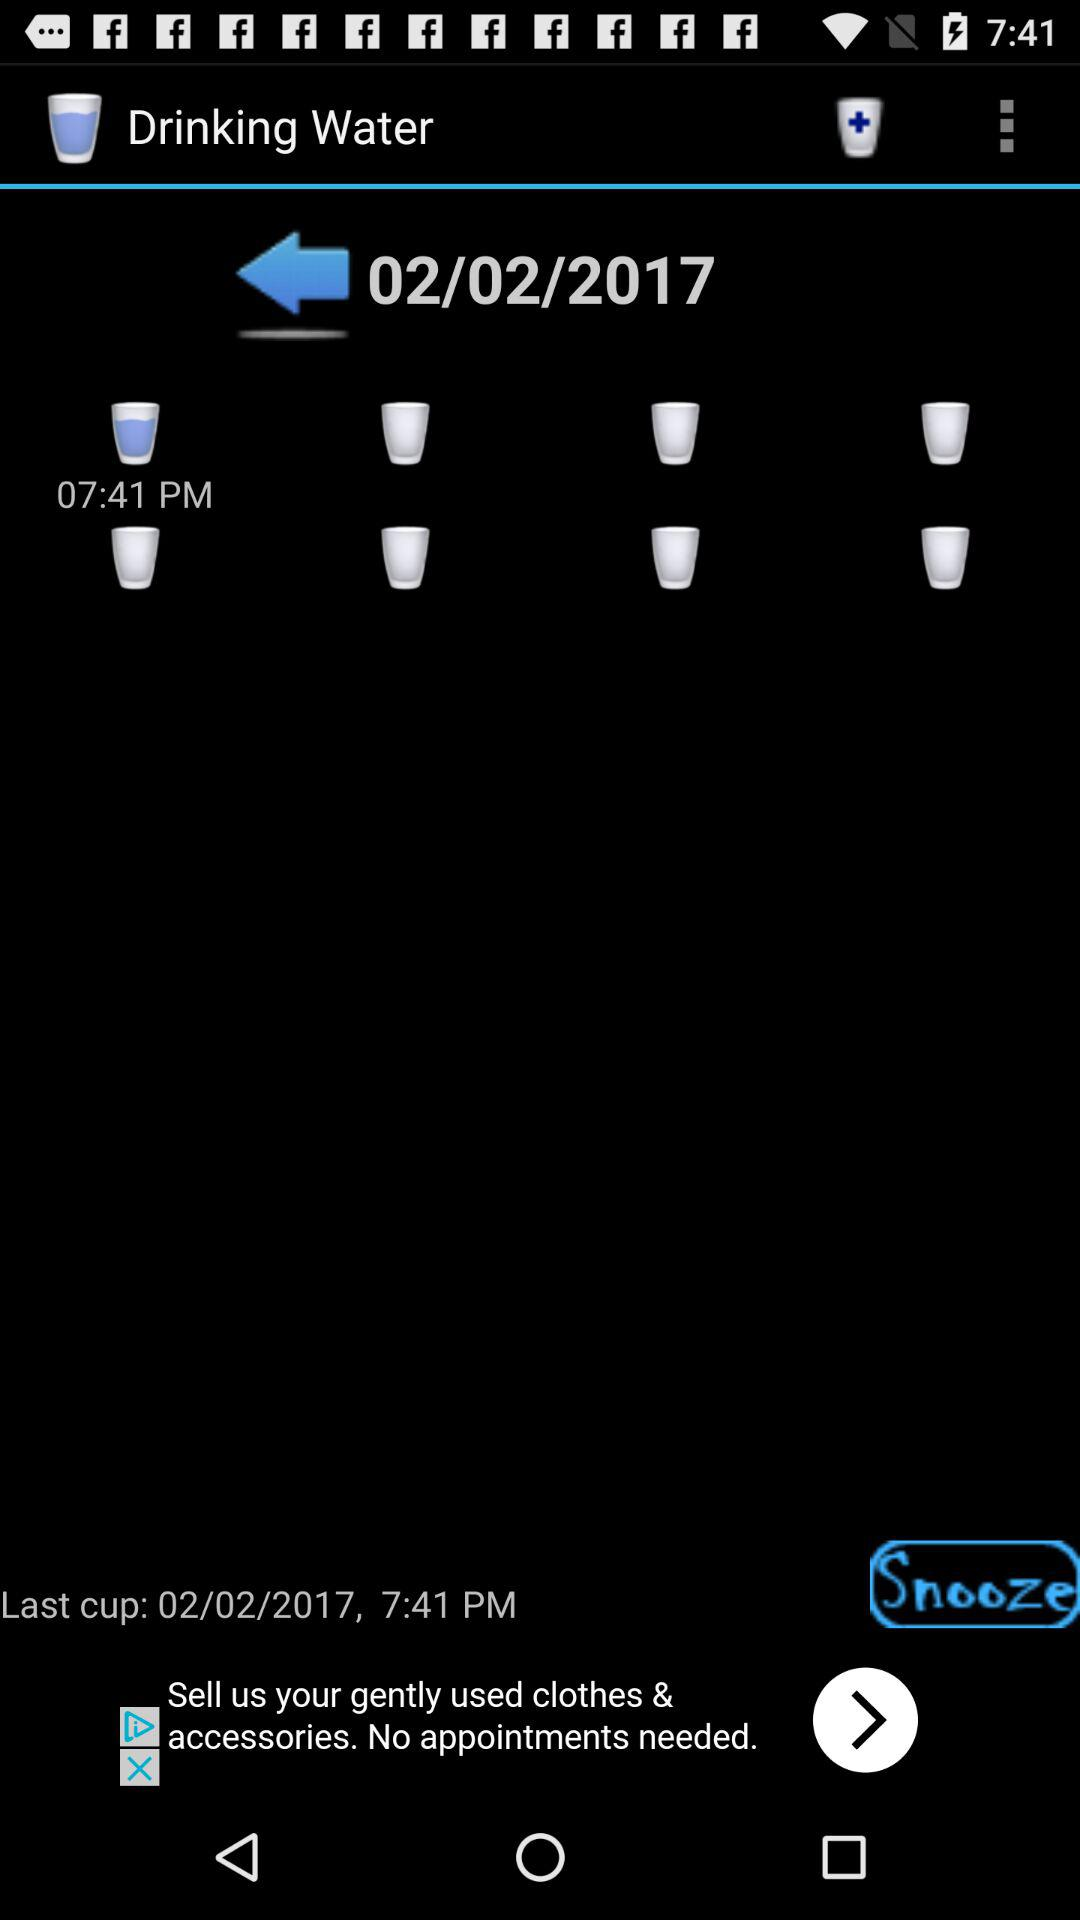What is the given date? The given date is February 2, 2017. 